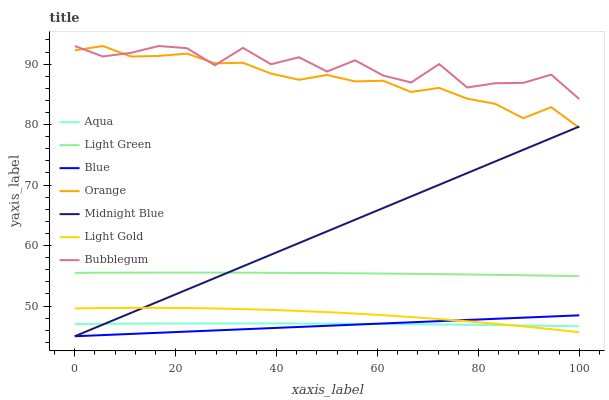Does Blue have the minimum area under the curve?
Answer yes or no. Yes. Does Bubblegum have the maximum area under the curve?
Answer yes or no. Yes. Does Midnight Blue have the minimum area under the curve?
Answer yes or no. No. Does Midnight Blue have the maximum area under the curve?
Answer yes or no. No. Is Midnight Blue the smoothest?
Answer yes or no. Yes. Is Bubblegum the roughest?
Answer yes or no. Yes. Is Aqua the smoothest?
Answer yes or no. No. Is Aqua the roughest?
Answer yes or no. No. Does Aqua have the lowest value?
Answer yes or no. No. Does Orange have the highest value?
Answer yes or no. Yes. Does Midnight Blue have the highest value?
Answer yes or no. No. Is Light Green less than Orange?
Answer yes or no. Yes. Is Light Green greater than Blue?
Answer yes or no. Yes. Does Midnight Blue intersect Light Gold?
Answer yes or no. Yes. Is Midnight Blue less than Light Gold?
Answer yes or no. No. Is Midnight Blue greater than Light Gold?
Answer yes or no. No. Does Light Green intersect Orange?
Answer yes or no. No. 